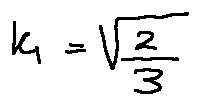<formula> <loc_0><loc_0><loc_500><loc_500>k _ { 1 } = \sqrt { \frac { 2 } { 3 } }</formula> 